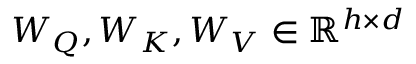Convert formula to latex. <formula><loc_0><loc_0><loc_500><loc_500>W _ { Q } , W _ { K } , W _ { V } \in \mathbb { R } ^ { h \times d }</formula> 